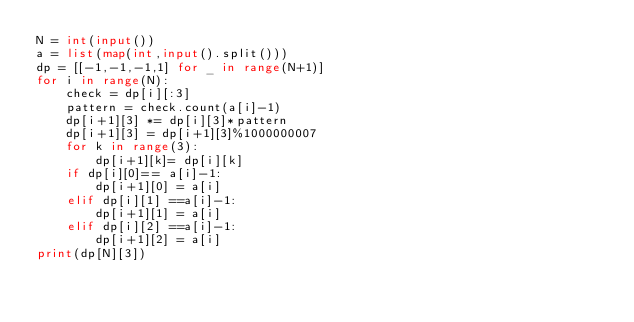Convert code to text. <code><loc_0><loc_0><loc_500><loc_500><_Python_>N = int(input())
a = list(map(int,input().split()))
dp = [[-1,-1,-1,1] for _ in range(N+1)]
for i in range(N):
    check = dp[i][:3]
    pattern = check.count(a[i]-1)
    dp[i+1][3] *= dp[i][3]*pattern
    dp[i+1][3] = dp[i+1][3]%1000000007
    for k in range(3):
        dp[i+1][k]= dp[i][k]
    if dp[i][0]== a[i]-1:
        dp[i+1][0] = a[i]
    elif dp[i][1] ==a[i]-1:
        dp[i+1][1] = a[i]
    elif dp[i][2] ==a[i]-1:
        dp[i+1][2] = a[i]
print(dp[N][3])</code> 